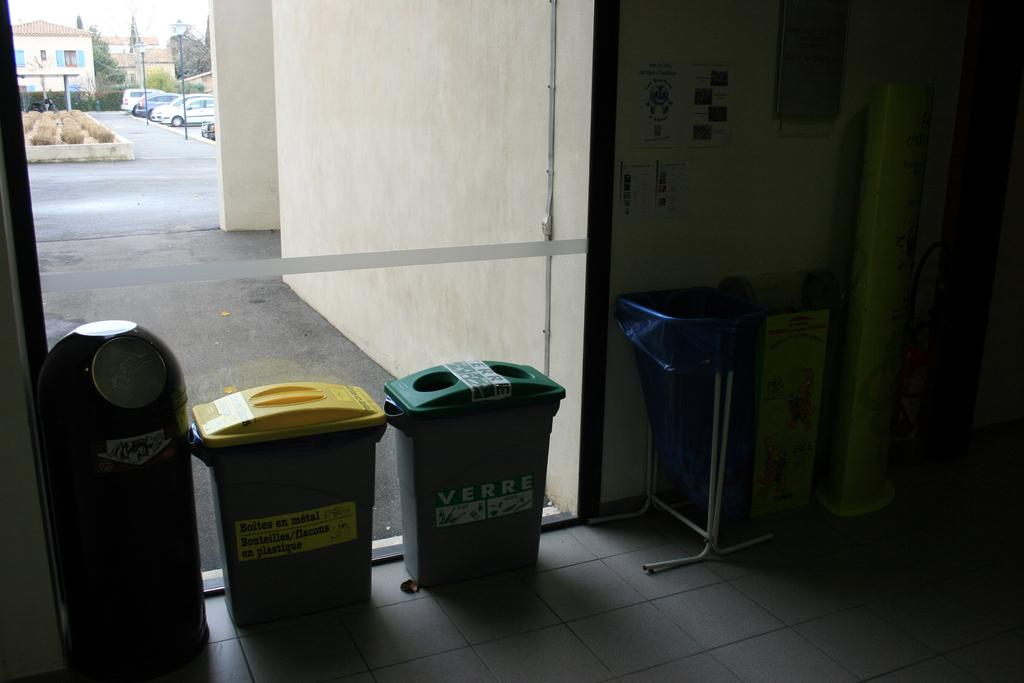<image>
Describe the image concisely. Green garbage can with a sticker that says "Verre" on it. 